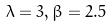Convert formula to latex. <formula><loc_0><loc_0><loc_500><loc_500>\lambda = 3 , \beta = 2 . 5</formula> 